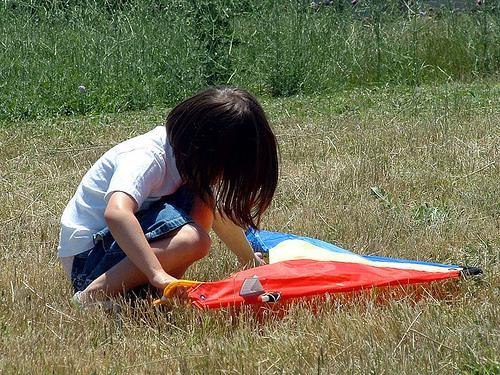Question: what is the child playing with?
Choices:
A. Video game.
B. Phone.
C. A kite.
D. Toy Car.
Answer with the letter. Answer: C Question: what is the middle color on the kite?
Choices:
A. Red.
B. White.
C. Blue.
D. Purple.
Answer with the letter. Answer: B Question: what color is the girl's skirt?
Choices:
A. Red.
B. Blue.
C. White.
D. Brown.
Answer with the letter. Answer: B Question: who is playing with the kite?
Choices:
A. The child.
B. The woman.
C. The boy.
D. The girl.
Answer with the letter. Answer: A 